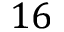Convert formula to latex. <formula><loc_0><loc_0><loc_500><loc_500>1 6</formula> 